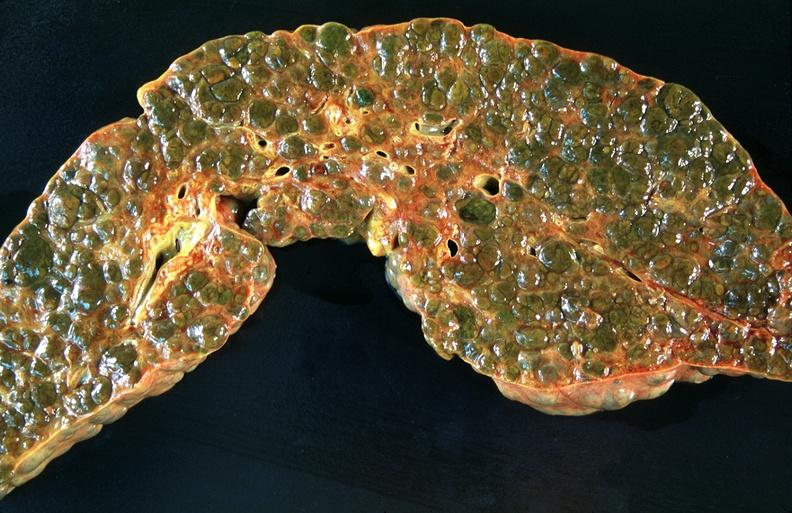s fallopian tube present?
Answer the question using a single word or phrase. No 